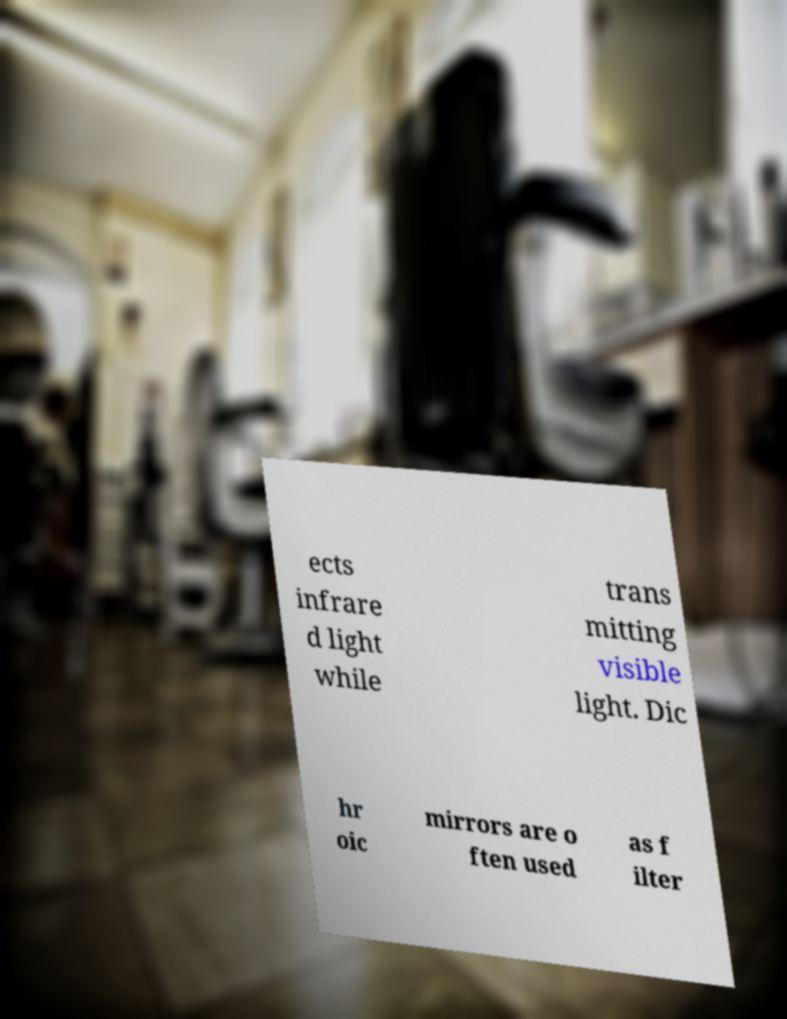There's text embedded in this image that I need extracted. Can you transcribe it verbatim? ects infrare d light while trans mitting visible light. Dic hr oic mirrors are o ften used as f ilter 